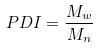<formula> <loc_0><loc_0><loc_500><loc_500>P D I = \frac { M _ { w } } { M _ { n } }</formula> 